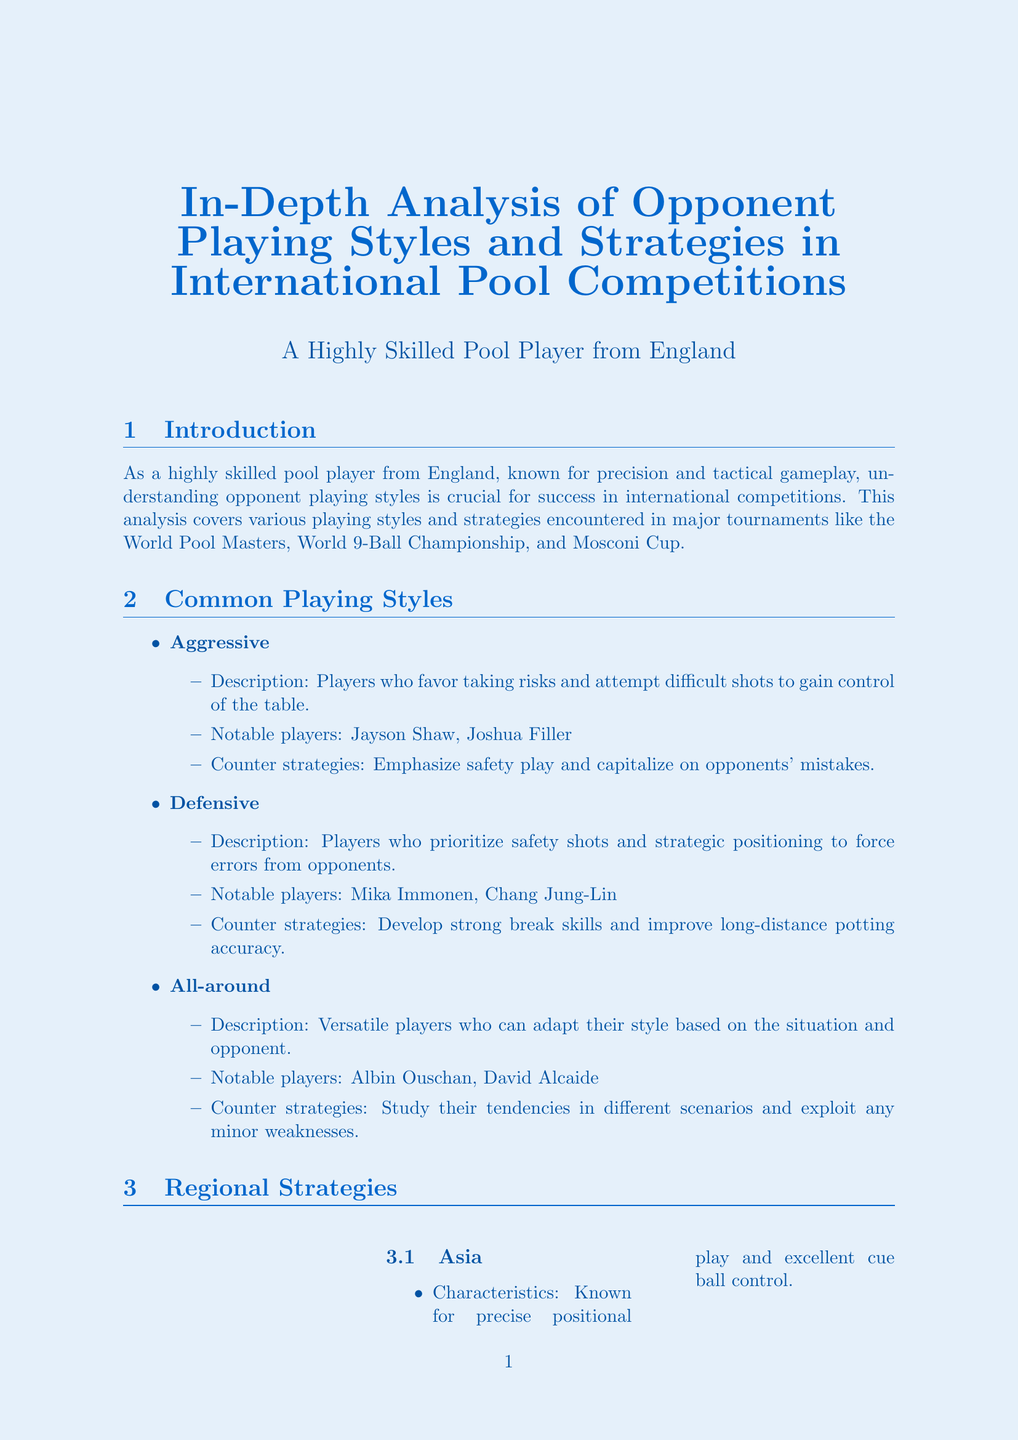What is the main focus of the analysis? The main focus is to understand opponent playing styles and strategies in international competitions.
Answer: opponent playing styles and strategies Which tournament has a single-elimination format? The competitive format specified in the document for this tournament type is single-elimination.
Answer: World Pool Masters Name one notable aggressive player. A notable player who uses aggressive playing style is provided in the document.
Answer: Jayson Shaw What is the key consideration for the World 9-Ball Championship? The document outlines a specific characteristic that is important during this championship.
Answer: Stamina What characteristics define Europe as a playing region? The document describes the tactical approach often displayed by players from Europe.
Answer: Balanced approach with strong tactical awareness How should a player adapt to Asian opponents? The document suggests an adaptation tip relating to improving specific skills against Asian players.
Answer: Improve cue ball control Which tool is used for video analysis in this report? The document mentions a specific type of software for reviewing past matches.
Answer: Kinovea What is emphasized for the Mosconi Cup? The key aspect highlighted in the document for success in this team event.
Answer: Strong communication with teammates 